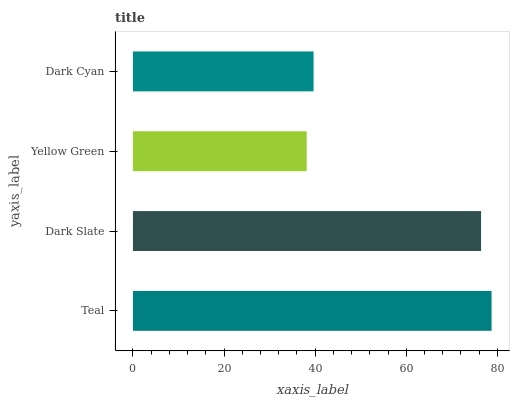Is Yellow Green the minimum?
Answer yes or no. Yes. Is Teal the maximum?
Answer yes or no. Yes. Is Dark Slate the minimum?
Answer yes or no. No. Is Dark Slate the maximum?
Answer yes or no. No. Is Teal greater than Dark Slate?
Answer yes or no. Yes. Is Dark Slate less than Teal?
Answer yes or no. Yes. Is Dark Slate greater than Teal?
Answer yes or no. No. Is Teal less than Dark Slate?
Answer yes or no. No. Is Dark Slate the high median?
Answer yes or no. Yes. Is Dark Cyan the low median?
Answer yes or no. Yes. Is Teal the high median?
Answer yes or no. No. Is Dark Slate the low median?
Answer yes or no. No. 